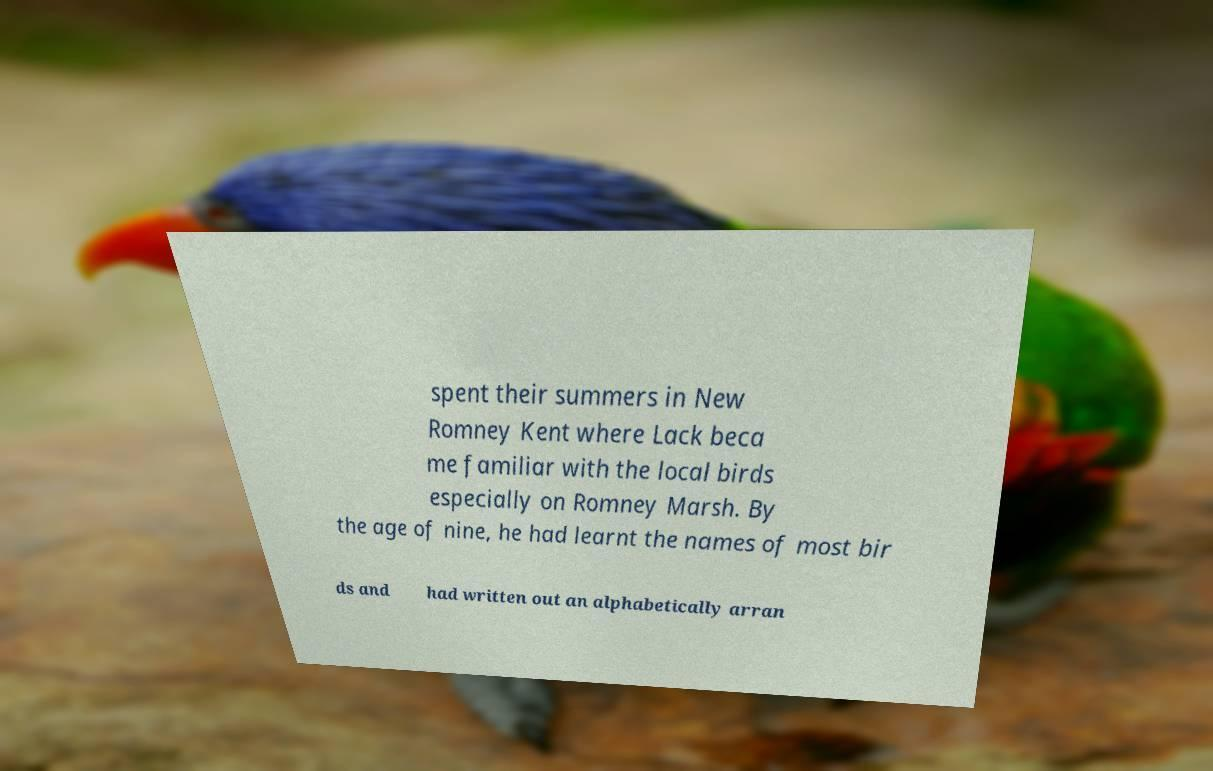Please identify and transcribe the text found in this image. spent their summers in New Romney Kent where Lack beca me familiar with the local birds especially on Romney Marsh. By the age of nine, he had learnt the names of most bir ds and had written out an alphabetically arran 